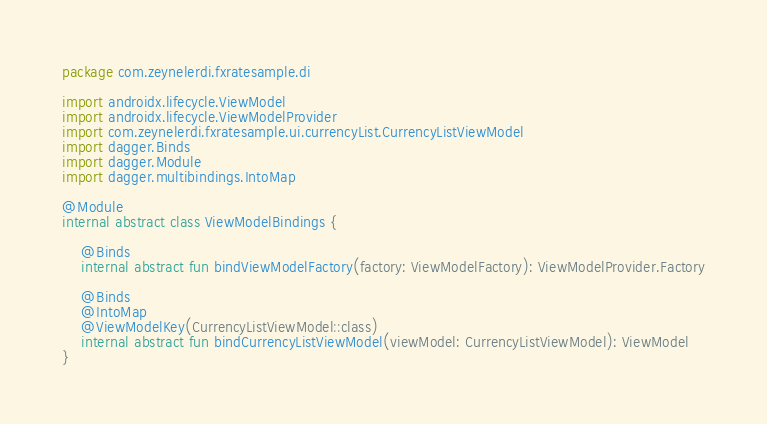Convert code to text. <code><loc_0><loc_0><loc_500><loc_500><_Kotlin_>package com.zeynelerdi.fxratesample.di

import androidx.lifecycle.ViewModel
import androidx.lifecycle.ViewModelProvider
import com.zeynelerdi.fxratesample.ui.currencyList.CurrencyListViewModel
import dagger.Binds
import dagger.Module
import dagger.multibindings.IntoMap

@Module
internal abstract class ViewModelBindings {

    @Binds
    internal abstract fun bindViewModelFactory(factory: ViewModelFactory): ViewModelProvider.Factory

    @Binds
    @IntoMap
    @ViewModelKey(CurrencyListViewModel::class)
    internal abstract fun bindCurrencyListViewModel(viewModel: CurrencyListViewModel): ViewModel
}
</code> 